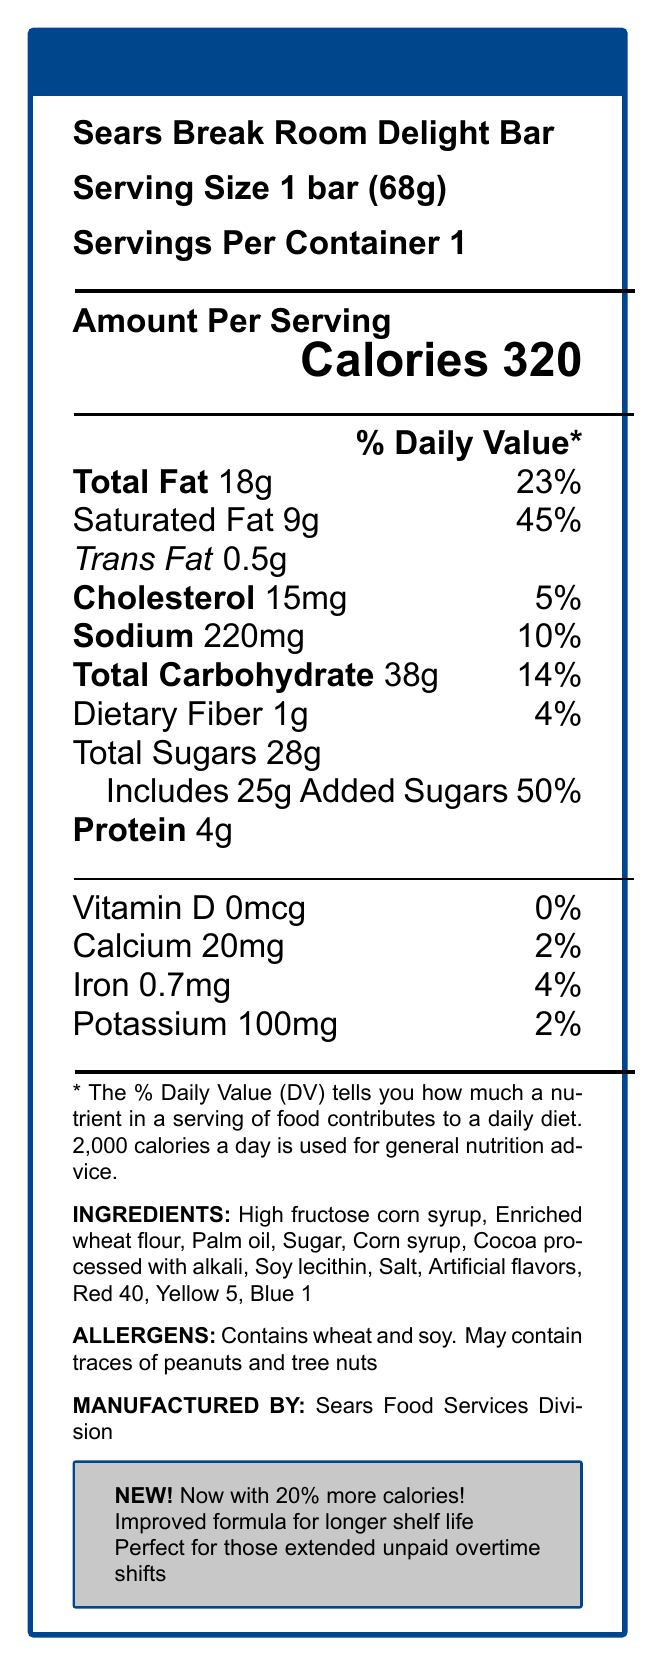What is the serving size of the Sears Break Room Delight Bar? According to the Nutrition Facts Label, the serving size is specified as "1 bar (68g)."
Answer: 1 bar (68g) How many calories are in one Sears Break Room Delight Bar? The label states that there are 320 calories in one serving of the bar, and since one serving size is one bar, it contains 320 calories.
Answer: 320 What percentage of the daily value of saturated fat does one bar contain? The document notes that the saturated fat content is 9g, which corresponds to 45% of the daily value.
Answer: 45% What two ingredients contribute most to the sugar content? The ingredients list includes "High fructose corn syrup" and "Sugar" as prominent components likely contributing to the high sugar content.
Answer: High fructose corn syrup, Sugar What is the amount of sodium in one serving? As per the Nutrition Facts, there are 220mg of sodium in one serving.
Answer: 220mg Which of the following ingredients listed is an artificial color? A. Soy lecithin B. Salt C. Red 40 D. Palm oil The ingredient list includes "Red 40," which is known to be an artificial color.
Answer: C. Red 40 What is the percentage daily value for added sugars? A. 25% B. 30% C. 50% D. 75% The label shows that the added sugars amount to 25g, corresponding to 50% of the daily value.
Answer: C. 50% Does the product contain any dietary fiber? The document states that each serving provides 1g of dietary fiber, which is 4% of the daily value.
Answer: Yes Summarize the nutritional profile of the Sears Break Room Delight Bar. This summary consolidates all the key nutritional information from the document, providing a comprehensive overview.
Answer: The Sears Break Room Delight Bar contains 320 calories per bar, with significant amounts of fat, sugar, and sodium. It has 18g of total fat, 9g of which are saturated, and 0.5g of trans fat. The bar contains 28g of total sugars which includes 25g of added sugars, representing 50% of the daily value. Additionally, it has 220mg of sodium and minor amounts of essential nutrients like calcium, iron, and potassium. The bar is primarily composed of high fructose corn syrup, enriched wheat flour, palm oil, and various other ingredients including artificial flavors and colors. What additional information is provided about the product? The document lists these additional selling points in a highlighted box.
Answer: "Now with 20% more calories!", "Improved formula for longer shelf life", and "Perfect for those extended unpaid overtime shifts" Can the exact amount of Red 40 in the bar be determined from the label? The ingredient list mentions "Red 40," but the exact quantity used in the product is not specified in the document.
Answer: No 